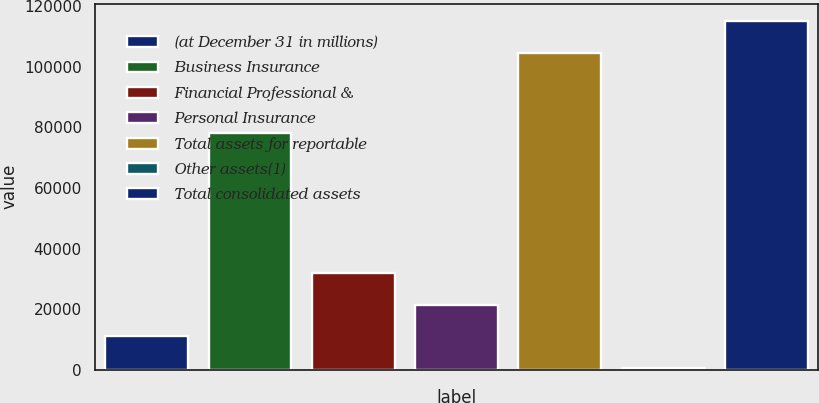Convert chart to OTSL. <chart><loc_0><loc_0><loc_500><loc_500><bar_chart><fcel>(at December 31 in millions)<fcel>Business Insurance<fcel>Financial Professional &<fcel>Personal Insurance<fcel>Total assets for reportable<fcel>Other assets(1)<fcel>Total consolidated assets<nl><fcel>11064.4<fcel>78119<fcel>31979.2<fcel>21521.8<fcel>104574<fcel>607<fcel>115031<nl></chart> 